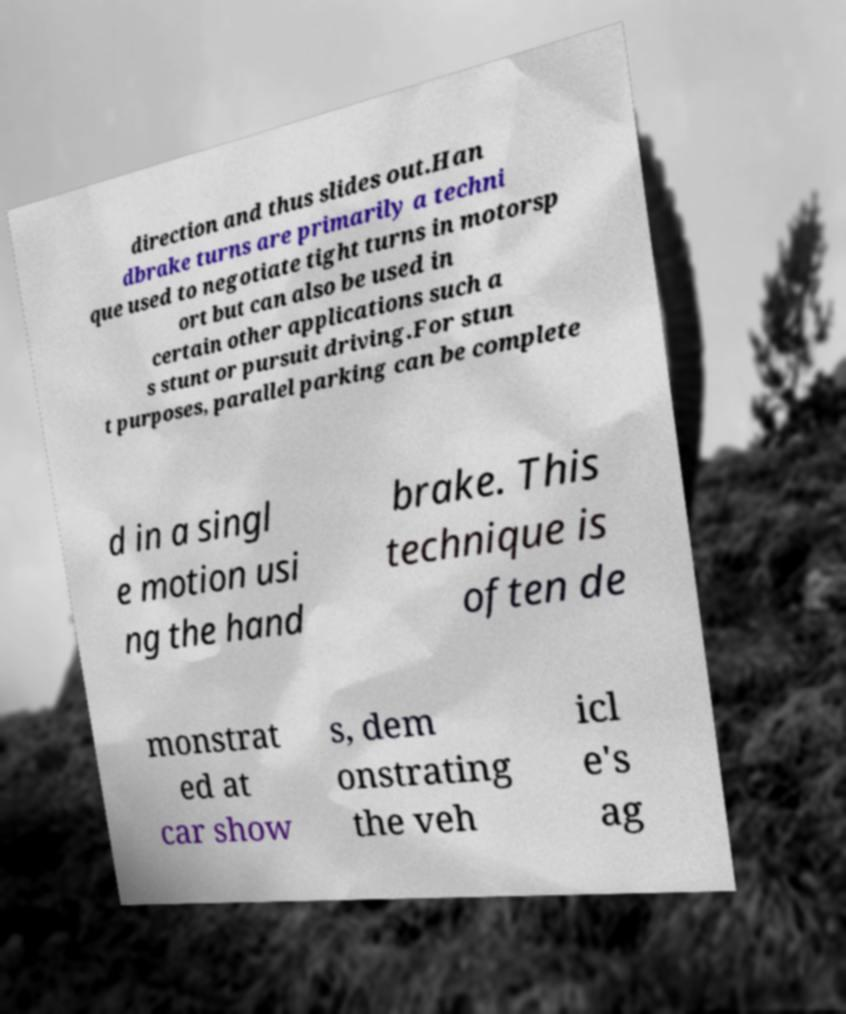There's text embedded in this image that I need extracted. Can you transcribe it verbatim? direction and thus slides out.Han dbrake turns are primarily a techni que used to negotiate tight turns in motorsp ort but can also be used in certain other applications such a s stunt or pursuit driving.For stun t purposes, parallel parking can be complete d in a singl e motion usi ng the hand brake. This technique is often de monstrat ed at car show s, dem onstrating the veh icl e's ag 